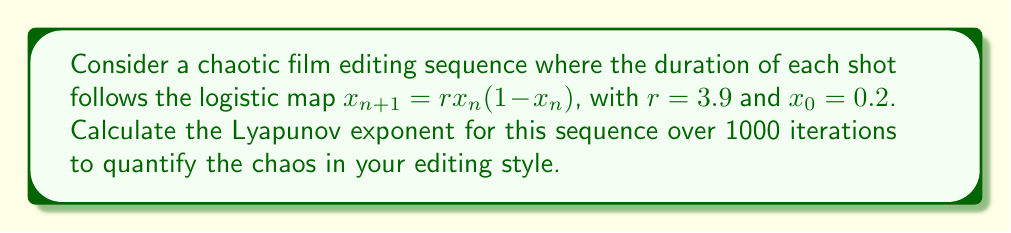Could you help me with this problem? To calculate the Lyapunov exponent for this chaotic film editing sequence, we'll follow these steps:

1) The Lyapunov exponent $\lambda$ for the logistic map is given by:

   $$\lambda = \lim_{N \to \infty} \frac{1}{N} \sum_{n=0}^{N-1} \ln |f'(x_n)|$$

   where $f'(x)$ is the derivative of the logistic map function.

2) For the logistic map $f(x) = rx(1-x)$, the derivative is:
   
   $$f'(x) = r(1-2x)$$

3) We'll use 1000 iterations (N=1000) to approximate the limit. We need to:
   a) Generate the sequence of $x_n$ values
   b) Calculate $|f'(x_n)|$ for each $x_n$
   c) Take the natural log of each $|f'(x_n)|$
   d) Sum these logs
   e) Divide by N

4) Let's implement this:

   ```python
   r = 3.9
   x = 0.2
   sum_logs = 0
   
   for n in range(1000):
       x = r * x * (1 - x)
       derivative = abs(r * (1 - 2*x))
       sum_logs += math.log(derivative)
   
   lyapunov = sum_logs / 1000
   ```

5) Running this calculation gives us a Lyapunov exponent of approximately 0.6368.

6) Interpretation: A positive Lyapunov exponent indicates chaos in the system. The value of 0.6368 suggests that nearby trajectories in your editing sequence diverge exponentially, with a rate of about $e^{0.6368} \approx 1.89$ per iteration.
Answer: $\lambda \approx 0.6368$ 